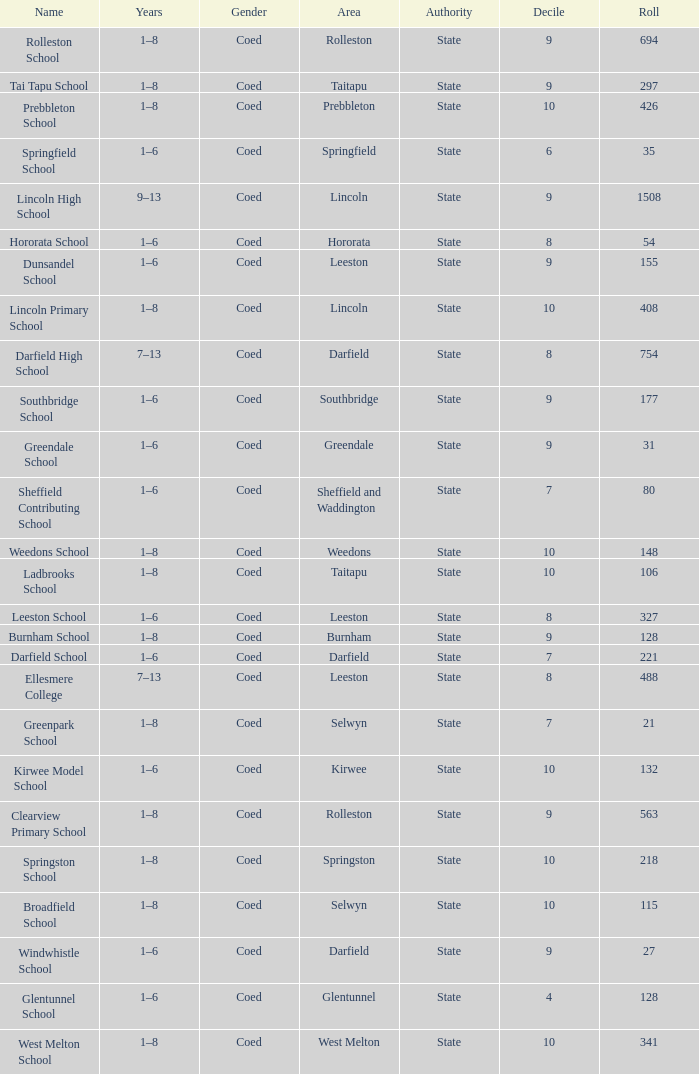What is the total of the roll with a Decile of 8, and an Area of hororata? 54.0. 